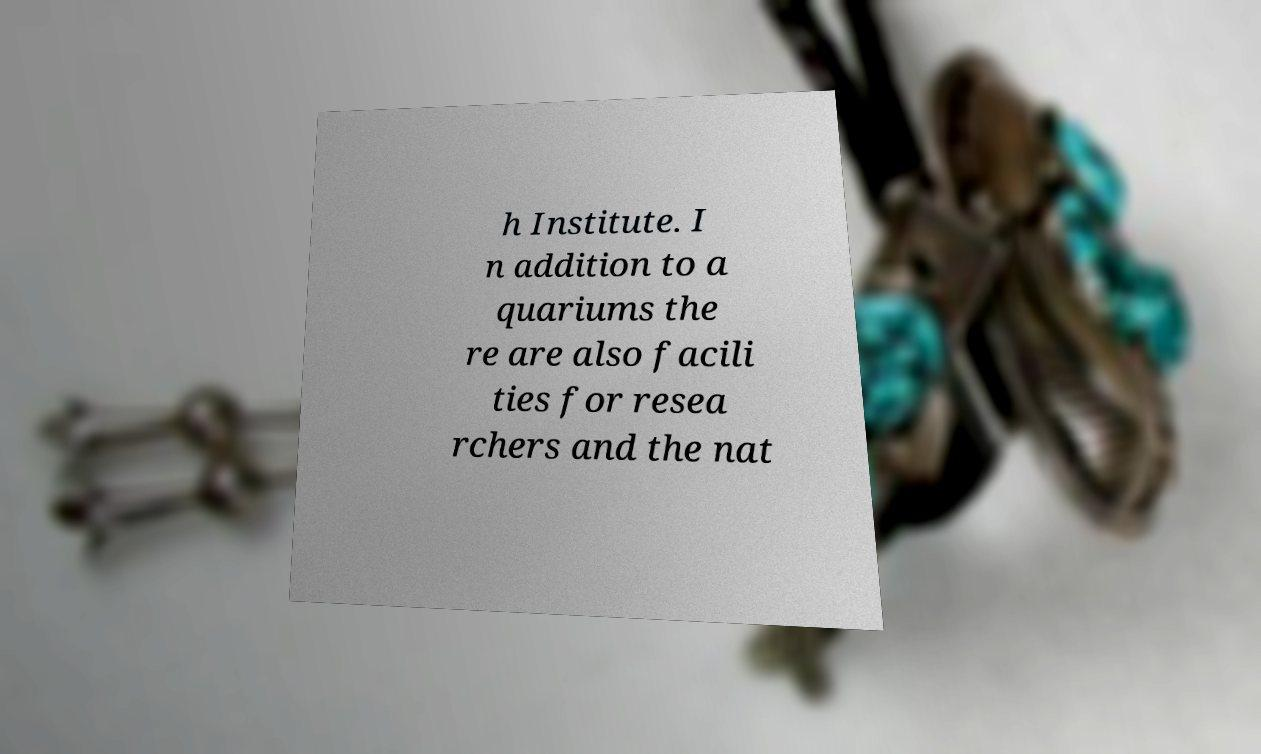Could you assist in decoding the text presented in this image and type it out clearly? h Institute. I n addition to a quariums the re are also facili ties for resea rchers and the nat 